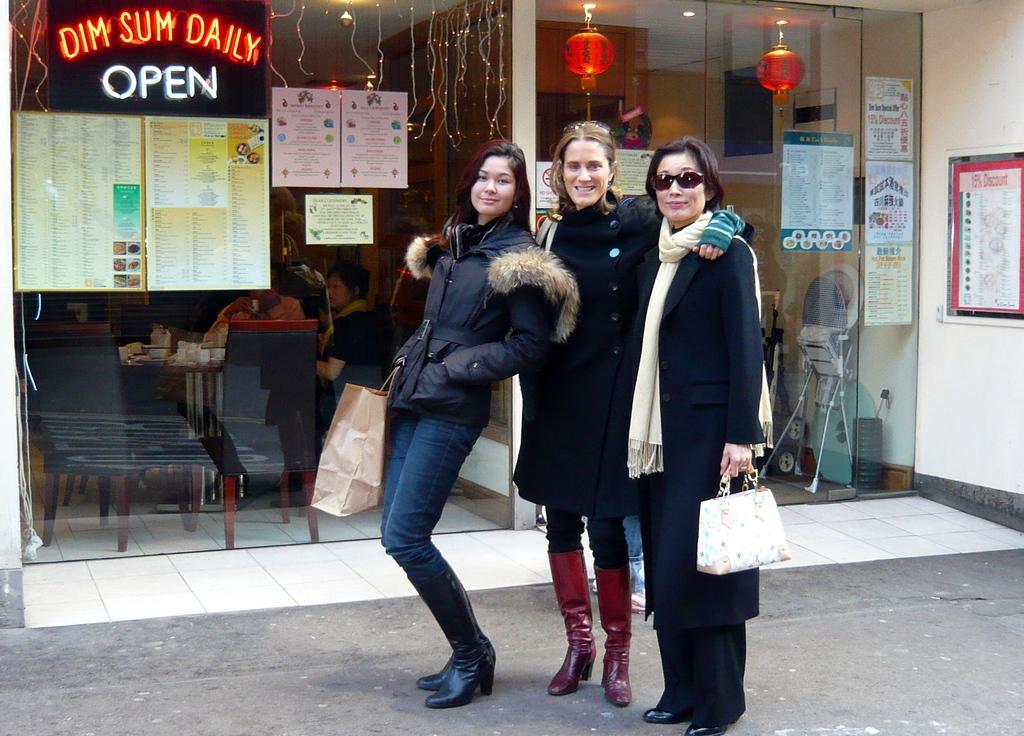Describe this image in one or two sentences. Here I can see three women wearing jackets, holding bags in the hands, standing on the road, smiling and giving pose for the picture. On the right side there is a wall on which a poster is attached. In the background there is a glass on which few posters and a board are attached. Behind the glass. I can see few people are sitting on the chairs and also there are some objects. At the top there are lanterns and few lights. 